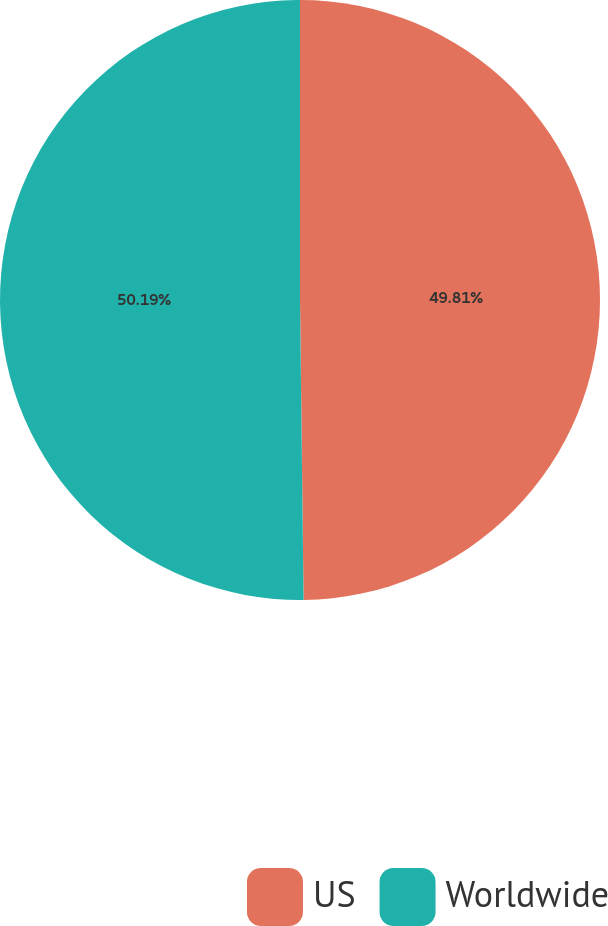<chart> <loc_0><loc_0><loc_500><loc_500><pie_chart><fcel>US<fcel>Worldwide<nl><fcel>49.81%<fcel>50.19%<nl></chart> 